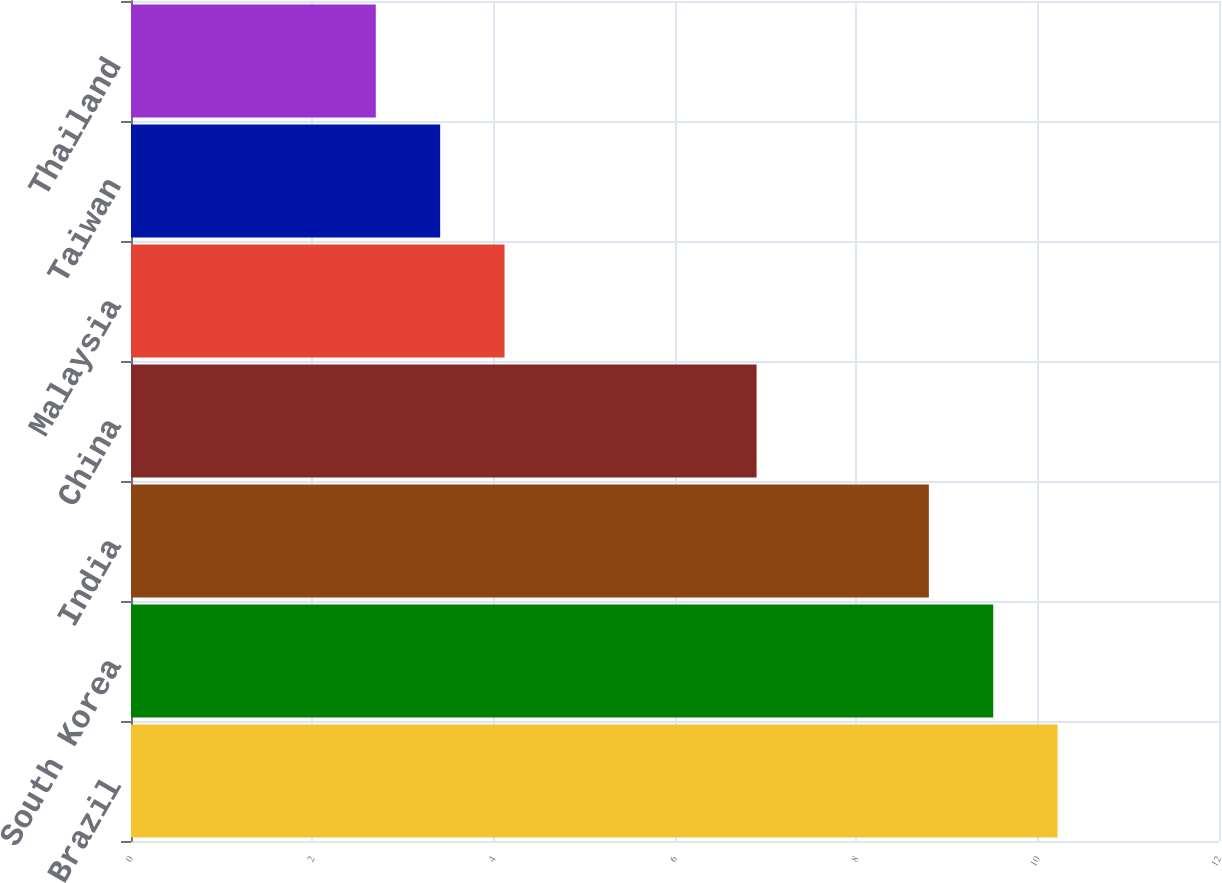Convert chart. <chart><loc_0><loc_0><loc_500><loc_500><bar_chart><fcel>Brazil<fcel>South Korea<fcel>India<fcel>China<fcel>Malaysia<fcel>Taiwan<fcel>Thailand<nl><fcel>10.22<fcel>9.51<fcel>8.8<fcel>6.9<fcel>4.12<fcel>3.41<fcel>2.7<nl></chart> 